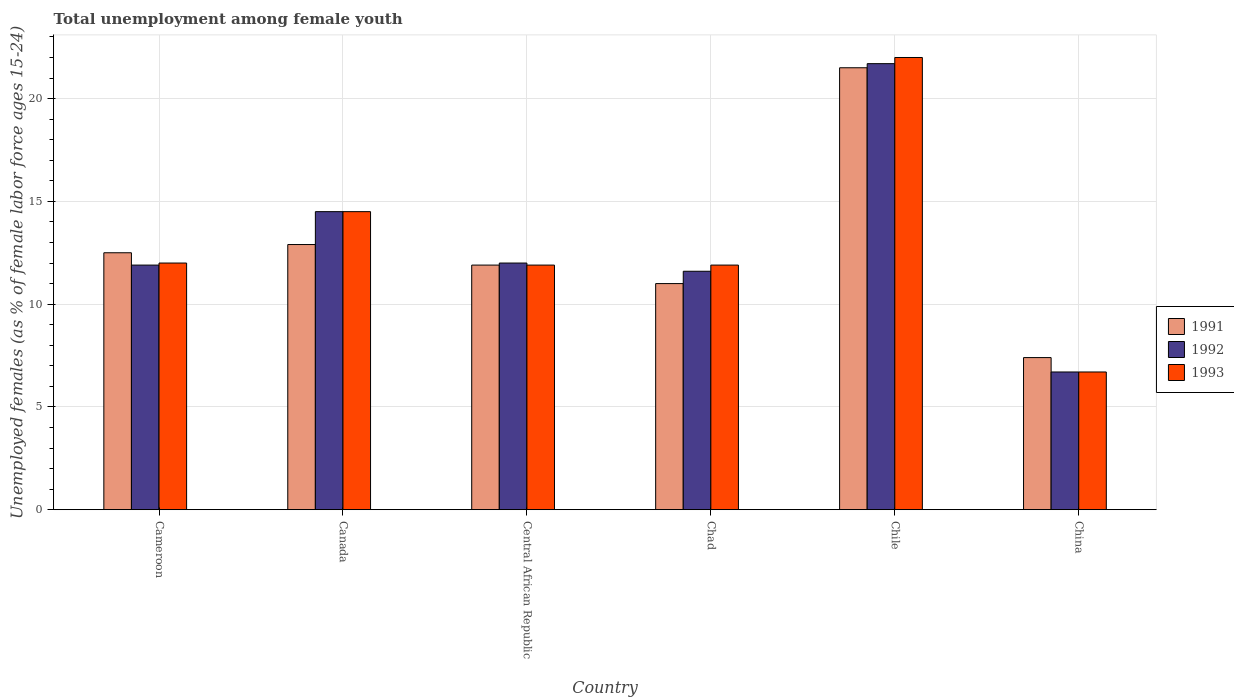How many different coloured bars are there?
Your answer should be very brief. 3. Are the number of bars per tick equal to the number of legend labels?
Offer a very short reply. Yes. Are the number of bars on each tick of the X-axis equal?
Ensure brevity in your answer.  Yes. How many bars are there on the 1st tick from the left?
Your answer should be very brief. 3. What is the label of the 3rd group of bars from the left?
Your answer should be compact. Central African Republic. In how many cases, is the number of bars for a given country not equal to the number of legend labels?
Your answer should be very brief. 0. What is the percentage of unemployed females in in 1992 in Chad?
Your response must be concise. 11.6. Across all countries, what is the minimum percentage of unemployed females in in 1992?
Ensure brevity in your answer.  6.7. In which country was the percentage of unemployed females in in 1991 minimum?
Your response must be concise. China. What is the total percentage of unemployed females in in 1993 in the graph?
Your answer should be very brief. 79. What is the difference between the percentage of unemployed females in in 1991 in Cameroon and that in Chile?
Offer a very short reply. -9. What is the difference between the percentage of unemployed females in in 1991 in Cameroon and the percentage of unemployed females in in 1992 in Chad?
Provide a short and direct response. 0.9. What is the average percentage of unemployed females in in 1993 per country?
Offer a very short reply. 13.17. What is the difference between the percentage of unemployed females in of/in 1991 and percentage of unemployed females in of/in 1993 in Central African Republic?
Offer a terse response. 0. What is the ratio of the percentage of unemployed females in in 1993 in Chad to that in Chile?
Provide a succinct answer. 0.54. Is the percentage of unemployed females in in 1991 in Cameroon less than that in Chile?
Give a very brief answer. Yes. What is the difference between the highest and the second highest percentage of unemployed females in in 1991?
Make the answer very short. -0.4. What is the difference between the highest and the lowest percentage of unemployed females in in 1991?
Your response must be concise. 14.1. In how many countries, is the percentage of unemployed females in in 1991 greater than the average percentage of unemployed females in in 1991 taken over all countries?
Your response must be concise. 2. Is the sum of the percentage of unemployed females in in 1993 in Cameroon and Canada greater than the maximum percentage of unemployed females in in 1991 across all countries?
Your response must be concise. Yes. What does the 3rd bar from the left in Chile represents?
Your response must be concise. 1993. What does the 2nd bar from the right in China represents?
Your answer should be compact. 1992. Is it the case that in every country, the sum of the percentage of unemployed females in in 1993 and percentage of unemployed females in in 1991 is greater than the percentage of unemployed females in in 1992?
Your answer should be very brief. Yes. How many countries are there in the graph?
Your answer should be very brief. 6. What is the difference between two consecutive major ticks on the Y-axis?
Provide a succinct answer. 5. Are the values on the major ticks of Y-axis written in scientific E-notation?
Ensure brevity in your answer.  No. How many legend labels are there?
Provide a short and direct response. 3. How are the legend labels stacked?
Give a very brief answer. Vertical. What is the title of the graph?
Provide a succinct answer. Total unemployment among female youth. What is the label or title of the Y-axis?
Ensure brevity in your answer.  Unemployed females (as % of female labor force ages 15-24). What is the Unemployed females (as % of female labor force ages 15-24) in 1992 in Cameroon?
Offer a terse response. 11.9. What is the Unemployed females (as % of female labor force ages 15-24) of 1991 in Canada?
Offer a terse response. 12.9. What is the Unemployed females (as % of female labor force ages 15-24) in 1992 in Canada?
Give a very brief answer. 14.5. What is the Unemployed females (as % of female labor force ages 15-24) in 1991 in Central African Republic?
Your response must be concise. 11.9. What is the Unemployed females (as % of female labor force ages 15-24) of 1992 in Central African Republic?
Make the answer very short. 12. What is the Unemployed females (as % of female labor force ages 15-24) in 1993 in Central African Republic?
Your answer should be compact. 11.9. What is the Unemployed females (as % of female labor force ages 15-24) of 1992 in Chad?
Your response must be concise. 11.6. What is the Unemployed females (as % of female labor force ages 15-24) in 1993 in Chad?
Keep it short and to the point. 11.9. What is the Unemployed females (as % of female labor force ages 15-24) in 1991 in Chile?
Provide a short and direct response. 21.5. What is the Unemployed females (as % of female labor force ages 15-24) of 1992 in Chile?
Your answer should be compact. 21.7. What is the Unemployed females (as % of female labor force ages 15-24) of 1991 in China?
Your answer should be compact. 7.4. What is the Unemployed females (as % of female labor force ages 15-24) in 1992 in China?
Give a very brief answer. 6.7. What is the Unemployed females (as % of female labor force ages 15-24) of 1993 in China?
Provide a short and direct response. 6.7. Across all countries, what is the maximum Unemployed females (as % of female labor force ages 15-24) in 1991?
Make the answer very short. 21.5. Across all countries, what is the maximum Unemployed females (as % of female labor force ages 15-24) of 1992?
Keep it short and to the point. 21.7. Across all countries, what is the maximum Unemployed females (as % of female labor force ages 15-24) of 1993?
Your answer should be compact. 22. Across all countries, what is the minimum Unemployed females (as % of female labor force ages 15-24) of 1991?
Your answer should be compact. 7.4. Across all countries, what is the minimum Unemployed females (as % of female labor force ages 15-24) in 1992?
Your answer should be compact. 6.7. Across all countries, what is the minimum Unemployed females (as % of female labor force ages 15-24) in 1993?
Make the answer very short. 6.7. What is the total Unemployed females (as % of female labor force ages 15-24) of 1991 in the graph?
Make the answer very short. 77.2. What is the total Unemployed females (as % of female labor force ages 15-24) of 1992 in the graph?
Give a very brief answer. 78.4. What is the total Unemployed females (as % of female labor force ages 15-24) of 1993 in the graph?
Provide a succinct answer. 79. What is the difference between the Unemployed females (as % of female labor force ages 15-24) in 1992 in Cameroon and that in Canada?
Your answer should be very brief. -2.6. What is the difference between the Unemployed females (as % of female labor force ages 15-24) in 1993 in Cameroon and that in Central African Republic?
Offer a terse response. 0.1. What is the difference between the Unemployed females (as % of female labor force ages 15-24) in 1991 in Cameroon and that in Chad?
Provide a short and direct response. 1.5. What is the difference between the Unemployed females (as % of female labor force ages 15-24) of 1992 in Cameroon and that in Chile?
Provide a succinct answer. -9.8. What is the difference between the Unemployed females (as % of female labor force ages 15-24) of 1993 in Cameroon and that in Chile?
Make the answer very short. -10. What is the difference between the Unemployed females (as % of female labor force ages 15-24) in 1991 in Cameroon and that in China?
Give a very brief answer. 5.1. What is the difference between the Unemployed females (as % of female labor force ages 15-24) of 1993 in Cameroon and that in China?
Keep it short and to the point. 5.3. What is the difference between the Unemployed females (as % of female labor force ages 15-24) in 1992 in Canada and that in Central African Republic?
Your response must be concise. 2.5. What is the difference between the Unemployed females (as % of female labor force ages 15-24) of 1991 in Canada and that in Chad?
Your response must be concise. 1.9. What is the difference between the Unemployed females (as % of female labor force ages 15-24) in 1991 in Canada and that in Chile?
Provide a short and direct response. -8.6. What is the difference between the Unemployed females (as % of female labor force ages 15-24) of 1992 in Canada and that in Chile?
Keep it short and to the point. -7.2. What is the difference between the Unemployed females (as % of female labor force ages 15-24) of 1993 in Canada and that in Chile?
Provide a short and direct response. -7.5. What is the difference between the Unemployed females (as % of female labor force ages 15-24) of 1991 in Canada and that in China?
Give a very brief answer. 5.5. What is the difference between the Unemployed females (as % of female labor force ages 15-24) of 1993 in Canada and that in China?
Make the answer very short. 7.8. What is the difference between the Unemployed females (as % of female labor force ages 15-24) of 1992 in Central African Republic and that in Chad?
Your answer should be very brief. 0.4. What is the difference between the Unemployed females (as % of female labor force ages 15-24) in 1993 in Central African Republic and that in Chad?
Your response must be concise. 0. What is the difference between the Unemployed females (as % of female labor force ages 15-24) of 1992 in Central African Republic and that in Chile?
Your answer should be very brief. -9.7. What is the difference between the Unemployed females (as % of female labor force ages 15-24) in 1993 in Central African Republic and that in Chile?
Make the answer very short. -10.1. What is the difference between the Unemployed females (as % of female labor force ages 15-24) of 1991 in Chad and that in Chile?
Your answer should be compact. -10.5. What is the difference between the Unemployed females (as % of female labor force ages 15-24) of 1992 in Chad and that in Chile?
Your answer should be compact. -10.1. What is the difference between the Unemployed females (as % of female labor force ages 15-24) in 1993 in Chad and that in Chile?
Your response must be concise. -10.1. What is the difference between the Unemployed females (as % of female labor force ages 15-24) in 1992 in Chad and that in China?
Make the answer very short. 4.9. What is the difference between the Unemployed females (as % of female labor force ages 15-24) in 1993 in Chad and that in China?
Provide a succinct answer. 5.2. What is the difference between the Unemployed females (as % of female labor force ages 15-24) of 1991 in Cameroon and the Unemployed females (as % of female labor force ages 15-24) of 1992 in Canada?
Offer a terse response. -2. What is the difference between the Unemployed females (as % of female labor force ages 15-24) in 1991 in Cameroon and the Unemployed females (as % of female labor force ages 15-24) in 1993 in Canada?
Offer a terse response. -2. What is the difference between the Unemployed females (as % of female labor force ages 15-24) in 1991 in Cameroon and the Unemployed females (as % of female labor force ages 15-24) in 1992 in Central African Republic?
Give a very brief answer. 0.5. What is the difference between the Unemployed females (as % of female labor force ages 15-24) of 1991 in Cameroon and the Unemployed females (as % of female labor force ages 15-24) of 1993 in Central African Republic?
Provide a succinct answer. 0.6. What is the difference between the Unemployed females (as % of female labor force ages 15-24) of 1991 in Cameroon and the Unemployed females (as % of female labor force ages 15-24) of 1992 in Chad?
Ensure brevity in your answer.  0.9. What is the difference between the Unemployed females (as % of female labor force ages 15-24) of 1991 in Cameroon and the Unemployed females (as % of female labor force ages 15-24) of 1993 in Chad?
Make the answer very short. 0.6. What is the difference between the Unemployed females (as % of female labor force ages 15-24) in 1991 in Cameroon and the Unemployed females (as % of female labor force ages 15-24) in 1993 in Chile?
Your response must be concise. -9.5. What is the difference between the Unemployed females (as % of female labor force ages 15-24) of 1992 in Cameroon and the Unemployed females (as % of female labor force ages 15-24) of 1993 in Chile?
Give a very brief answer. -10.1. What is the difference between the Unemployed females (as % of female labor force ages 15-24) of 1991 in Cameroon and the Unemployed females (as % of female labor force ages 15-24) of 1993 in China?
Keep it short and to the point. 5.8. What is the difference between the Unemployed females (as % of female labor force ages 15-24) in 1991 in Canada and the Unemployed females (as % of female labor force ages 15-24) in 1993 in Central African Republic?
Make the answer very short. 1. What is the difference between the Unemployed females (as % of female labor force ages 15-24) of 1992 in Canada and the Unemployed females (as % of female labor force ages 15-24) of 1993 in Central African Republic?
Provide a short and direct response. 2.6. What is the difference between the Unemployed females (as % of female labor force ages 15-24) in 1991 in Canada and the Unemployed females (as % of female labor force ages 15-24) in 1992 in Chad?
Make the answer very short. 1.3. What is the difference between the Unemployed females (as % of female labor force ages 15-24) in 1991 in Canada and the Unemployed females (as % of female labor force ages 15-24) in 1992 in China?
Give a very brief answer. 6.2. What is the difference between the Unemployed females (as % of female labor force ages 15-24) in 1991 in Canada and the Unemployed females (as % of female labor force ages 15-24) in 1993 in China?
Provide a succinct answer. 6.2. What is the difference between the Unemployed females (as % of female labor force ages 15-24) in 1992 in Canada and the Unemployed females (as % of female labor force ages 15-24) in 1993 in China?
Make the answer very short. 7.8. What is the difference between the Unemployed females (as % of female labor force ages 15-24) of 1991 in Central African Republic and the Unemployed females (as % of female labor force ages 15-24) of 1992 in Chad?
Your answer should be very brief. 0.3. What is the difference between the Unemployed females (as % of female labor force ages 15-24) of 1991 in Central African Republic and the Unemployed females (as % of female labor force ages 15-24) of 1992 in Chile?
Offer a terse response. -9.8. What is the difference between the Unemployed females (as % of female labor force ages 15-24) of 1991 in Central African Republic and the Unemployed females (as % of female labor force ages 15-24) of 1993 in Chile?
Give a very brief answer. -10.1. What is the difference between the Unemployed females (as % of female labor force ages 15-24) in 1992 in Central African Republic and the Unemployed females (as % of female labor force ages 15-24) in 1993 in Chile?
Your answer should be very brief. -10. What is the difference between the Unemployed females (as % of female labor force ages 15-24) in 1991 in Central African Republic and the Unemployed females (as % of female labor force ages 15-24) in 1992 in China?
Make the answer very short. 5.2. What is the difference between the Unemployed females (as % of female labor force ages 15-24) in 1991 in Chad and the Unemployed females (as % of female labor force ages 15-24) in 1992 in Chile?
Provide a short and direct response. -10.7. What is the difference between the Unemployed females (as % of female labor force ages 15-24) in 1992 in Chad and the Unemployed females (as % of female labor force ages 15-24) in 1993 in Chile?
Give a very brief answer. -10.4. What is the difference between the Unemployed females (as % of female labor force ages 15-24) in 1991 in Chad and the Unemployed females (as % of female labor force ages 15-24) in 1992 in China?
Your answer should be compact. 4.3. What is the difference between the Unemployed females (as % of female labor force ages 15-24) in 1991 in Chad and the Unemployed females (as % of female labor force ages 15-24) in 1993 in China?
Offer a very short reply. 4.3. What is the difference between the Unemployed females (as % of female labor force ages 15-24) of 1991 in Chile and the Unemployed females (as % of female labor force ages 15-24) of 1992 in China?
Your answer should be compact. 14.8. What is the difference between the Unemployed females (as % of female labor force ages 15-24) in 1992 in Chile and the Unemployed females (as % of female labor force ages 15-24) in 1993 in China?
Offer a terse response. 15. What is the average Unemployed females (as % of female labor force ages 15-24) in 1991 per country?
Make the answer very short. 12.87. What is the average Unemployed females (as % of female labor force ages 15-24) in 1992 per country?
Your answer should be compact. 13.07. What is the average Unemployed females (as % of female labor force ages 15-24) of 1993 per country?
Ensure brevity in your answer.  13.17. What is the difference between the Unemployed females (as % of female labor force ages 15-24) in 1991 and Unemployed females (as % of female labor force ages 15-24) in 1993 in Canada?
Offer a very short reply. -1.6. What is the difference between the Unemployed females (as % of female labor force ages 15-24) of 1992 and Unemployed females (as % of female labor force ages 15-24) of 1993 in Canada?
Offer a very short reply. 0. What is the difference between the Unemployed females (as % of female labor force ages 15-24) in 1991 and Unemployed females (as % of female labor force ages 15-24) in 1993 in Central African Republic?
Ensure brevity in your answer.  0. What is the difference between the Unemployed females (as % of female labor force ages 15-24) in 1991 and Unemployed females (as % of female labor force ages 15-24) in 1992 in Chile?
Give a very brief answer. -0.2. What is the difference between the Unemployed females (as % of female labor force ages 15-24) in 1991 and Unemployed females (as % of female labor force ages 15-24) in 1993 in Chile?
Your response must be concise. -0.5. What is the difference between the Unemployed females (as % of female labor force ages 15-24) in 1992 and Unemployed females (as % of female labor force ages 15-24) in 1993 in Chile?
Your answer should be compact. -0.3. What is the difference between the Unemployed females (as % of female labor force ages 15-24) in 1992 and Unemployed females (as % of female labor force ages 15-24) in 1993 in China?
Provide a short and direct response. 0. What is the ratio of the Unemployed females (as % of female labor force ages 15-24) of 1991 in Cameroon to that in Canada?
Provide a succinct answer. 0.97. What is the ratio of the Unemployed females (as % of female labor force ages 15-24) of 1992 in Cameroon to that in Canada?
Ensure brevity in your answer.  0.82. What is the ratio of the Unemployed females (as % of female labor force ages 15-24) of 1993 in Cameroon to that in Canada?
Provide a succinct answer. 0.83. What is the ratio of the Unemployed females (as % of female labor force ages 15-24) in 1991 in Cameroon to that in Central African Republic?
Your answer should be compact. 1.05. What is the ratio of the Unemployed females (as % of female labor force ages 15-24) in 1993 in Cameroon to that in Central African Republic?
Your answer should be very brief. 1.01. What is the ratio of the Unemployed females (as % of female labor force ages 15-24) of 1991 in Cameroon to that in Chad?
Make the answer very short. 1.14. What is the ratio of the Unemployed females (as % of female labor force ages 15-24) of 1992 in Cameroon to that in Chad?
Make the answer very short. 1.03. What is the ratio of the Unemployed females (as % of female labor force ages 15-24) of 1993 in Cameroon to that in Chad?
Make the answer very short. 1.01. What is the ratio of the Unemployed females (as % of female labor force ages 15-24) of 1991 in Cameroon to that in Chile?
Your response must be concise. 0.58. What is the ratio of the Unemployed females (as % of female labor force ages 15-24) in 1992 in Cameroon to that in Chile?
Your answer should be very brief. 0.55. What is the ratio of the Unemployed females (as % of female labor force ages 15-24) in 1993 in Cameroon to that in Chile?
Give a very brief answer. 0.55. What is the ratio of the Unemployed females (as % of female labor force ages 15-24) of 1991 in Cameroon to that in China?
Make the answer very short. 1.69. What is the ratio of the Unemployed females (as % of female labor force ages 15-24) in 1992 in Cameroon to that in China?
Make the answer very short. 1.78. What is the ratio of the Unemployed females (as % of female labor force ages 15-24) of 1993 in Cameroon to that in China?
Your response must be concise. 1.79. What is the ratio of the Unemployed females (as % of female labor force ages 15-24) of 1991 in Canada to that in Central African Republic?
Offer a very short reply. 1.08. What is the ratio of the Unemployed females (as % of female labor force ages 15-24) in 1992 in Canada to that in Central African Republic?
Your response must be concise. 1.21. What is the ratio of the Unemployed females (as % of female labor force ages 15-24) in 1993 in Canada to that in Central African Republic?
Make the answer very short. 1.22. What is the ratio of the Unemployed females (as % of female labor force ages 15-24) of 1991 in Canada to that in Chad?
Your answer should be very brief. 1.17. What is the ratio of the Unemployed females (as % of female labor force ages 15-24) of 1992 in Canada to that in Chad?
Your answer should be compact. 1.25. What is the ratio of the Unemployed females (as % of female labor force ages 15-24) in 1993 in Canada to that in Chad?
Your response must be concise. 1.22. What is the ratio of the Unemployed females (as % of female labor force ages 15-24) of 1991 in Canada to that in Chile?
Your answer should be very brief. 0.6. What is the ratio of the Unemployed females (as % of female labor force ages 15-24) of 1992 in Canada to that in Chile?
Offer a terse response. 0.67. What is the ratio of the Unemployed females (as % of female labor force ages 15-24) of 1993 in Canada to that in Chile?
Your response must be concise. 0.66. What is the ratio of the Unemployed females (as % of female labor force ages 15-24) in 1991 in Canada to that in China?
Make the answer very short. 1.74. What is the ratio of the Unemployed females (as % of female labor force ages 15-24) in 1992 in Canada to that in China?
Offer a very short reply. 2.16. What is the ratio of the Unemployed females (as % of female labor force ages 15-24) of 1993 in Canada to that in China?
Make the answer very short. 2.16. What is the ratio of the Unemployed females (as % of female labor force ages 15-24) of 1991 in Central African Republic to that in Chad?
Your response must be concise. 1.08. What is the ratio of the Unemployed females (as % of female labor force ages 15-24) in 1992 in Central African Republic to that in Chad?
Offer a very short reply. 1.03. What is the ratio of the Unemployed females (as % of female labor force ages 15-24) of 1993 in Central African Republic to that in Chad?
Your answer should be very brief. 1. What is the ratio of the Unemployed females (as % of female labor force ages 15-24) of 1991 in Central African Republic to that in Chile?
Give a very brief answer. 0.55. What is the ratio of the Unemployed females (as % of female labor force ages 15-24) in 1992 in Central African Republic to that in Chile?
Give a very brief answer. 0.55. What is the ratio of the Unemployed females (as % of female labor force ages 15-24) in 1993 in Central African Republic to that in Chile?
Your answer should be compact. 0.54. What is the ratio of the Unemployed females (as % of female labor force ages 15-24) of 1991 in Central African Republic to that in China?
Offer a terse response. 1.61. What is the ratio of the Unemployed females (as % of female labor force ages 15-24) of 1992 in Central African Republic to that in China?
Offer a terse response. 1.79. What is the ratio of the Unemployed females (as % of female labor force ages 15-24) in 1993 in Central African Republic to that in China?
Give a very brief answer. 1.78. What is the ratio of the Unemployed females (as % of female labor force ages 15-24) of 1991 in Chad to that in Chile?
Make the answer very short. 0.51. What is the ratio of the Unemployed females (as % of female labor force ages 15-24) of 1992 in Chad to that in Chile?
Offer a very short reply. 0.53. What is the ratio of the Unemployed females (as % of female labor force ages 15-24) in 1993 in Chad to that in Chile?
Offer a terse response. 0.54. What is the ratio of the Unemployed females (as % of female labor force ages 15-24) of 1991 in Chad to that in China?
Give a very brief answer. 1.49. What is the ratio of the Unemployed females (as % of female labor force ages 15-24) in 1992 in Chad to that in China?
Provide a succinct answer. 1.73. What is the ratio of the Unemployed females (as % of female labor force ages 15-24) of 1993 in Chad to that in China?
Your answer should be compact. 1.78. What is the ratio of the Unemployed females (as % of female labor force ages 15-24) in 1991 in Chile to that in China?
Give a very brief answer. 2.91. What is the ratio of the Unemployed females (as % of female labor force ages 15-24) in 1992 in Chile to that in China?
Offer a terse response. 3.24. What is the ratio of the Unemployed females (as % of female labor force ages 15-24) of 1993 in Chile to that in China?
Provide a succinct answer. 3.28. What is the difference between the highest and the second highest Unemployed females (as % of female labor force ages 15-24) of 1993?
Your answer should be very brief. 7.5. What is the difference between the highest and the lowest Unemployed females (as % of female labor force ages 15-24) in 1991?
Your response must be concise. 14.1. What is the difference between the highest and the lowest Unemployed females (as % of female labor force ages 15-24) of 1993?
Your response must be concise. 15.3. 